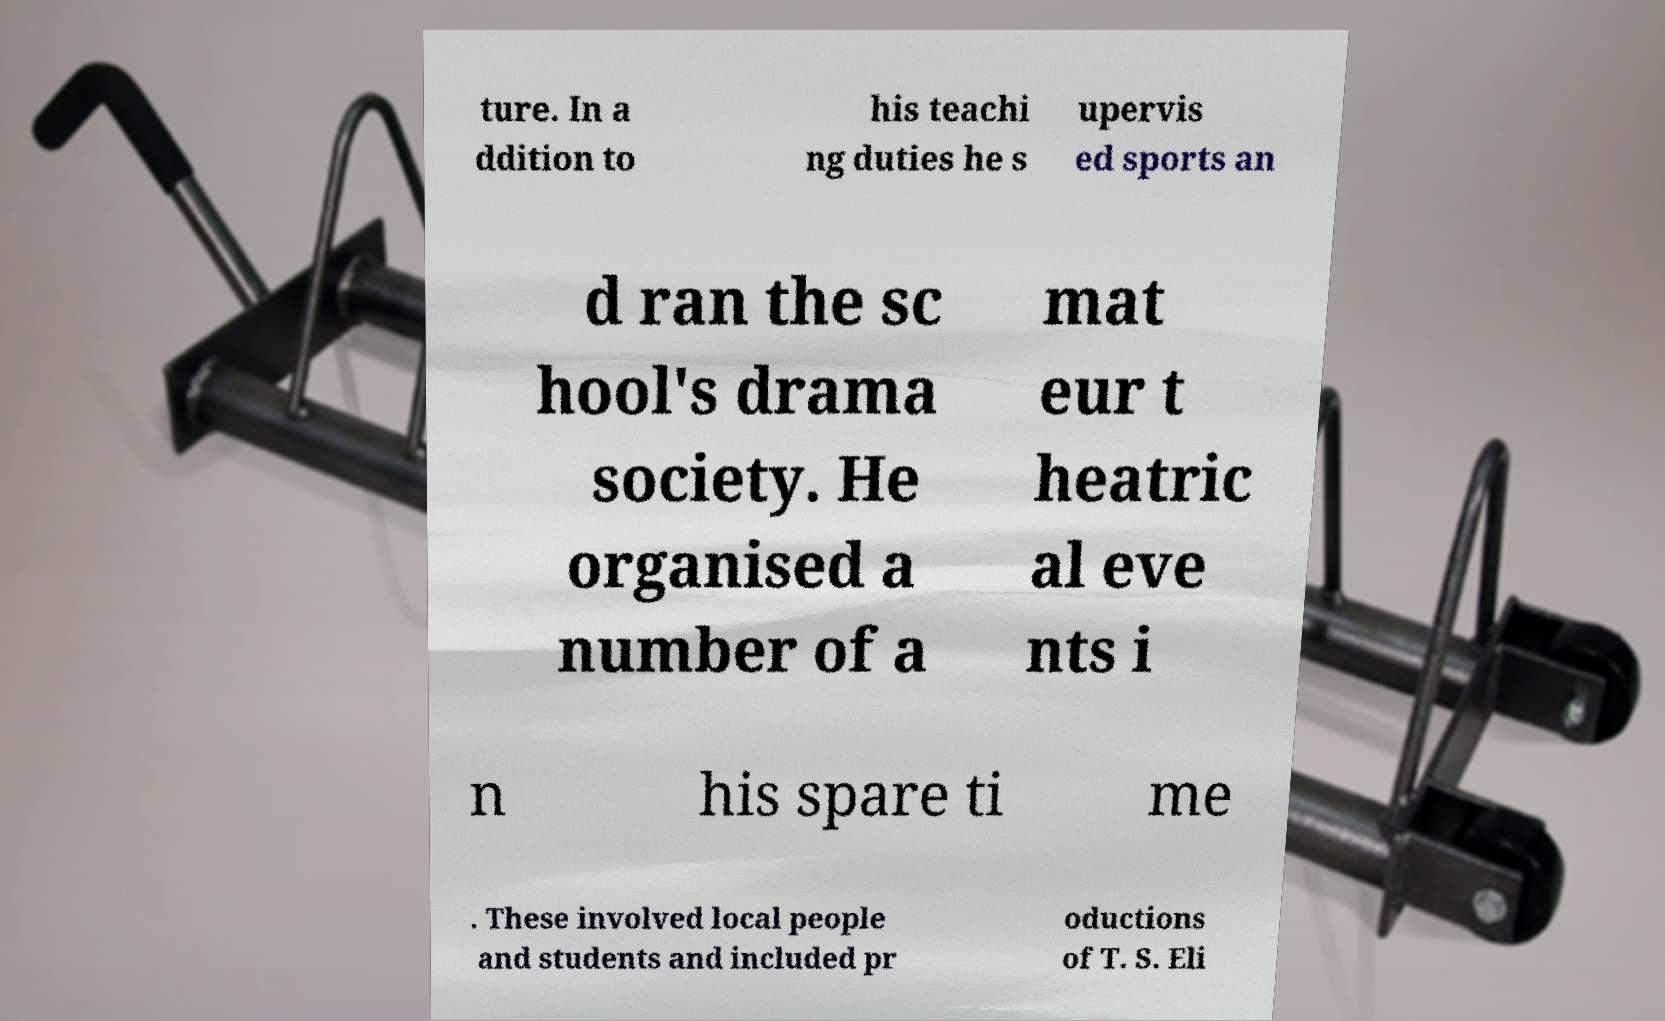What messages or text are displayed in this image? I need them in a readable, typed format. ture. In a ddition to his teachi ng duties he s upervis ed sports an d ran the sc hool's drama society. He organised a number of a mat eur t heatric al eve nts i n his spare ti me . These involved local people and students and included pr oductions of T. S. Eli 